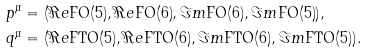<formula> <loc_0><loc_0><loc_500><loc_500>p ^ { \mu } & = ( \Re e { \tt F O ( 5 ) } , \Re e { \tt F O ( 6 ) } , \Im m { \tt F O ( 6 ) } , \Im m { \tt F O ( 5 ) } ) , \\ q ^ { \mu } & = ( \Re e { \tt F T O ( 5 ) } , \Re e { \tt F T O ( 6 ) } , \Im m { \tt F T O ( 6 ) } , \Im m { \tt F T O ( 5 ) } ) .</formula> 